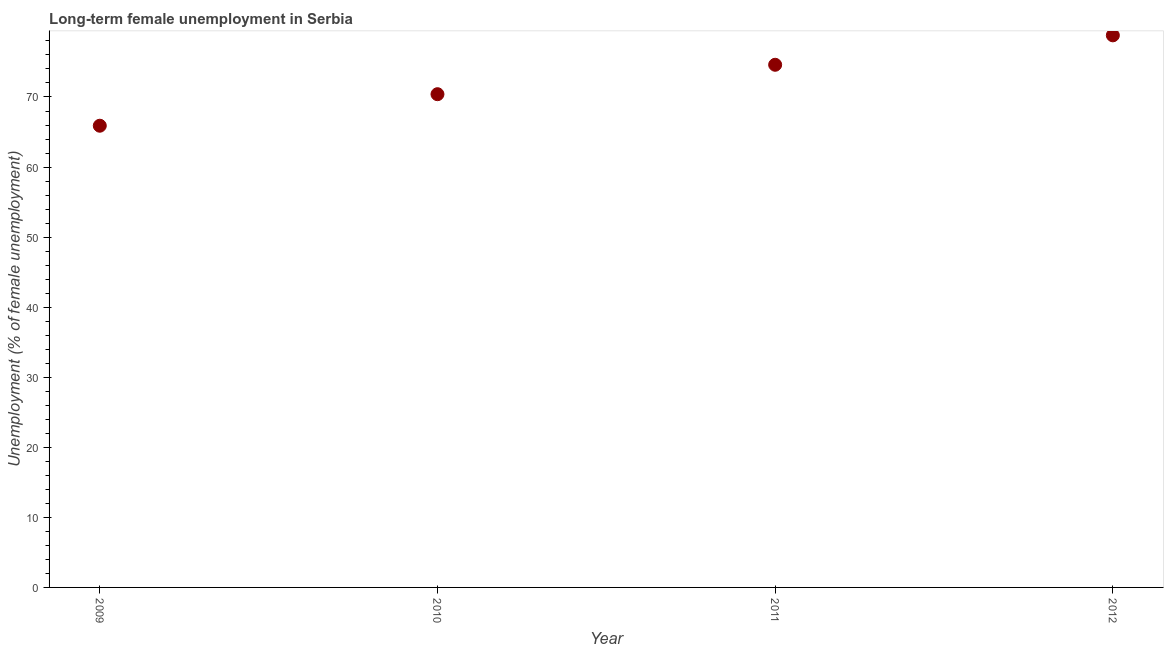What is the long-term female unemployment in 2009?
Your answer should be compact. 65.9. Across all years, what is the maximum long-term female unemployment?
Your answer should be compact. 78.8. Across all years, what is the minimum long-term female unemployment?
Offer a very short reply. 65.9. In which year was the long-term female unemployment minimum?
Ensure brevity in your answer.  2009. What is the sum of the long-term female unemployment?
Provide a succinct answer. 289.7. What is the difference between the long-term female unemployment in 2009 and 2011?
Provide a short and direct response. -8.7. What is the average long-term female unemployment per year?
Provide a short and direct response. 72.43. What is the median long-term female unemployment?
Your response must be concise. 72.5. In how many years, is the long-term female unemployment greater than 56 %?
Your answer should be very brief. 4. What is the ratio of the long-term female unemployment in 2009 to that in 2011?
Provide a short and direct response. 0.88. Is the long-term female unemployment in 2009 less than that in 2011?
Give a very brief answer. Yes. Is the difference between the long-term female unemployment in 2009 and 2011 greater than the difference between any two years?
Keep it short and to the point. No. What is the difference between the highest and the second highest long-term female unemployment?
Provide a short and direct response. 4.2. Is the sum of the long-term female unemployment in 2009 and 2012 greater than the maximum long-term female unemployment across all years?
Your response must be concise. Yes. What is the difference between the highest and the lowest long-term female unemployment?
Give a very brief answer. 12.9. In how many years, is the long-term female unemployment greater than the average long-term female unemployment taken over all years?
Provide a short and direct response. 2. How many dotlines are there?
Keep it short and to the point. 1. How many years are there in the graph?
Your answer should be very brief. 4. Does the graph contain grids?
Provide a succinct answer. No. What is the title of the graph?
Ensure brevity in your answer.  Long-term female unemployment in Serbia. What is the label or title of the Y-axis?
Ensure brevity in your answer.  Unemployment (% of female unemployment). What is the Unemployment (% of female unemployment) in 2009?
Keep it short and to the point. 65.9. What is the Unemployment (% of female unemployment) in 2010?
Give a very brief answer. 70.4. What is the Unemployment (% of female unemployment) in 2011?
Offer a very short reply. 74.6. What is the Unemployment (% of female unemployment) in 2012?
Provide a succinct answer. 78.8. What is the difference between the Unemployment (% of female unemployment) in 2009 and 2010?
Offer a terse response. -4.5. What is the difference between the Unemployment (% of female unemployment) in 2009 and 2011?
Your answer should be compact. -8.7. What is the difference between the Unemployment (% of female unemployment) in 2010 and 2011?
Provide a succinct answer. -4.2. What is the difference between the Unemployment (% of female unemployment) in 2010 and 2012?
Offer a terse response. -8.4. What is the ratio of the Unemployment (% of female unemployment) in 2009 to that in 2010?
Offer a very short reply. 0.94. What is the ratio of the Unemployment (% of female unemployment) in 2009 to that in 2011?
Keep it short and to the point. 0.88. What is the ratio of the Unemployment (% of female unemployment) in 2009 to that in 2012?
Your response must be concise. 0.84. What is the ratio of the Unemployment (% of female unemployment) in 2010 to that in 2011?
Your answer should be very brief. 0.94. What is the ratio of the Unemployment (% of female unemployment) in 2010 to that in 2012?
Provide a succinct answer. 0.89. What is the ratio of the Unemployment (% of female unemployment) in 2011 to that in 2012?
Your answer should be compact. 0.95. 